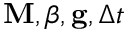<formula> <loc_0><loc_0><loc_500><loc_500>M , \beta , g , \Delta t</formula> 